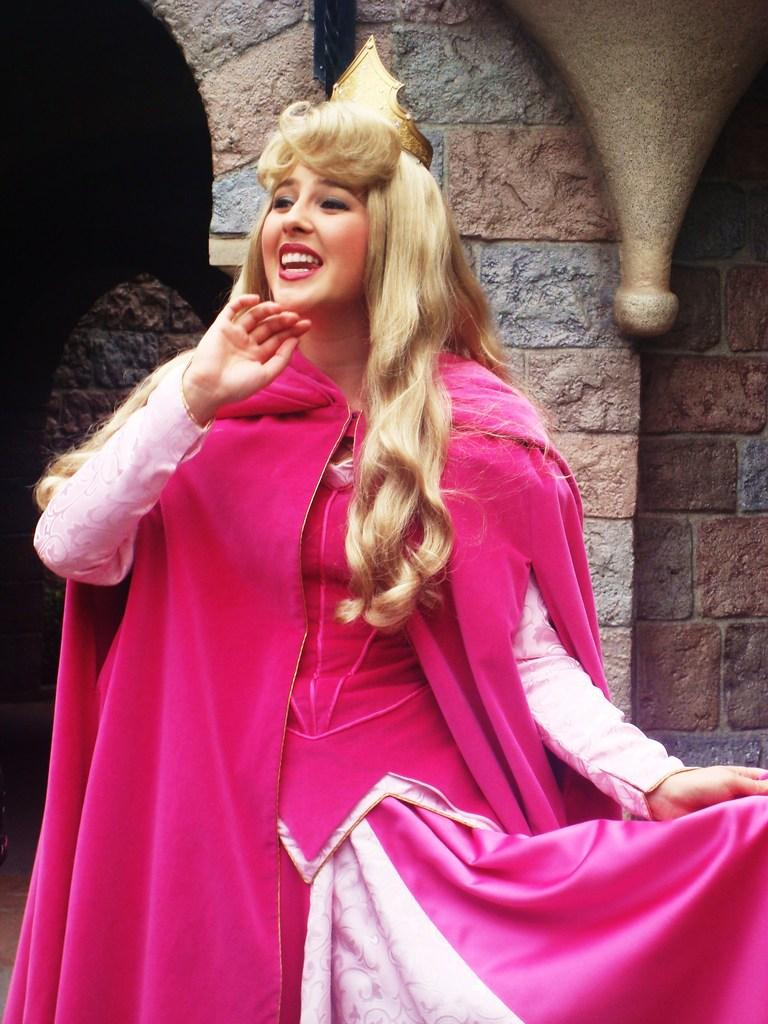Who is present in the image? There is a woman in the image. What is the woman doing in the image? The woman is standing in the image. What is the woman's facial expression in the image? The woman is smiling in the image. What object can be seen in the image? There is a crown in the image. What can be seen in the background of the image? There is a wall in the background of the image. What type of pot is being used by the army in the image? There is no army or pot present in the image. What boundary is visible in the image? There is no boundary visible in the image; only a wall can be seen in the background. 